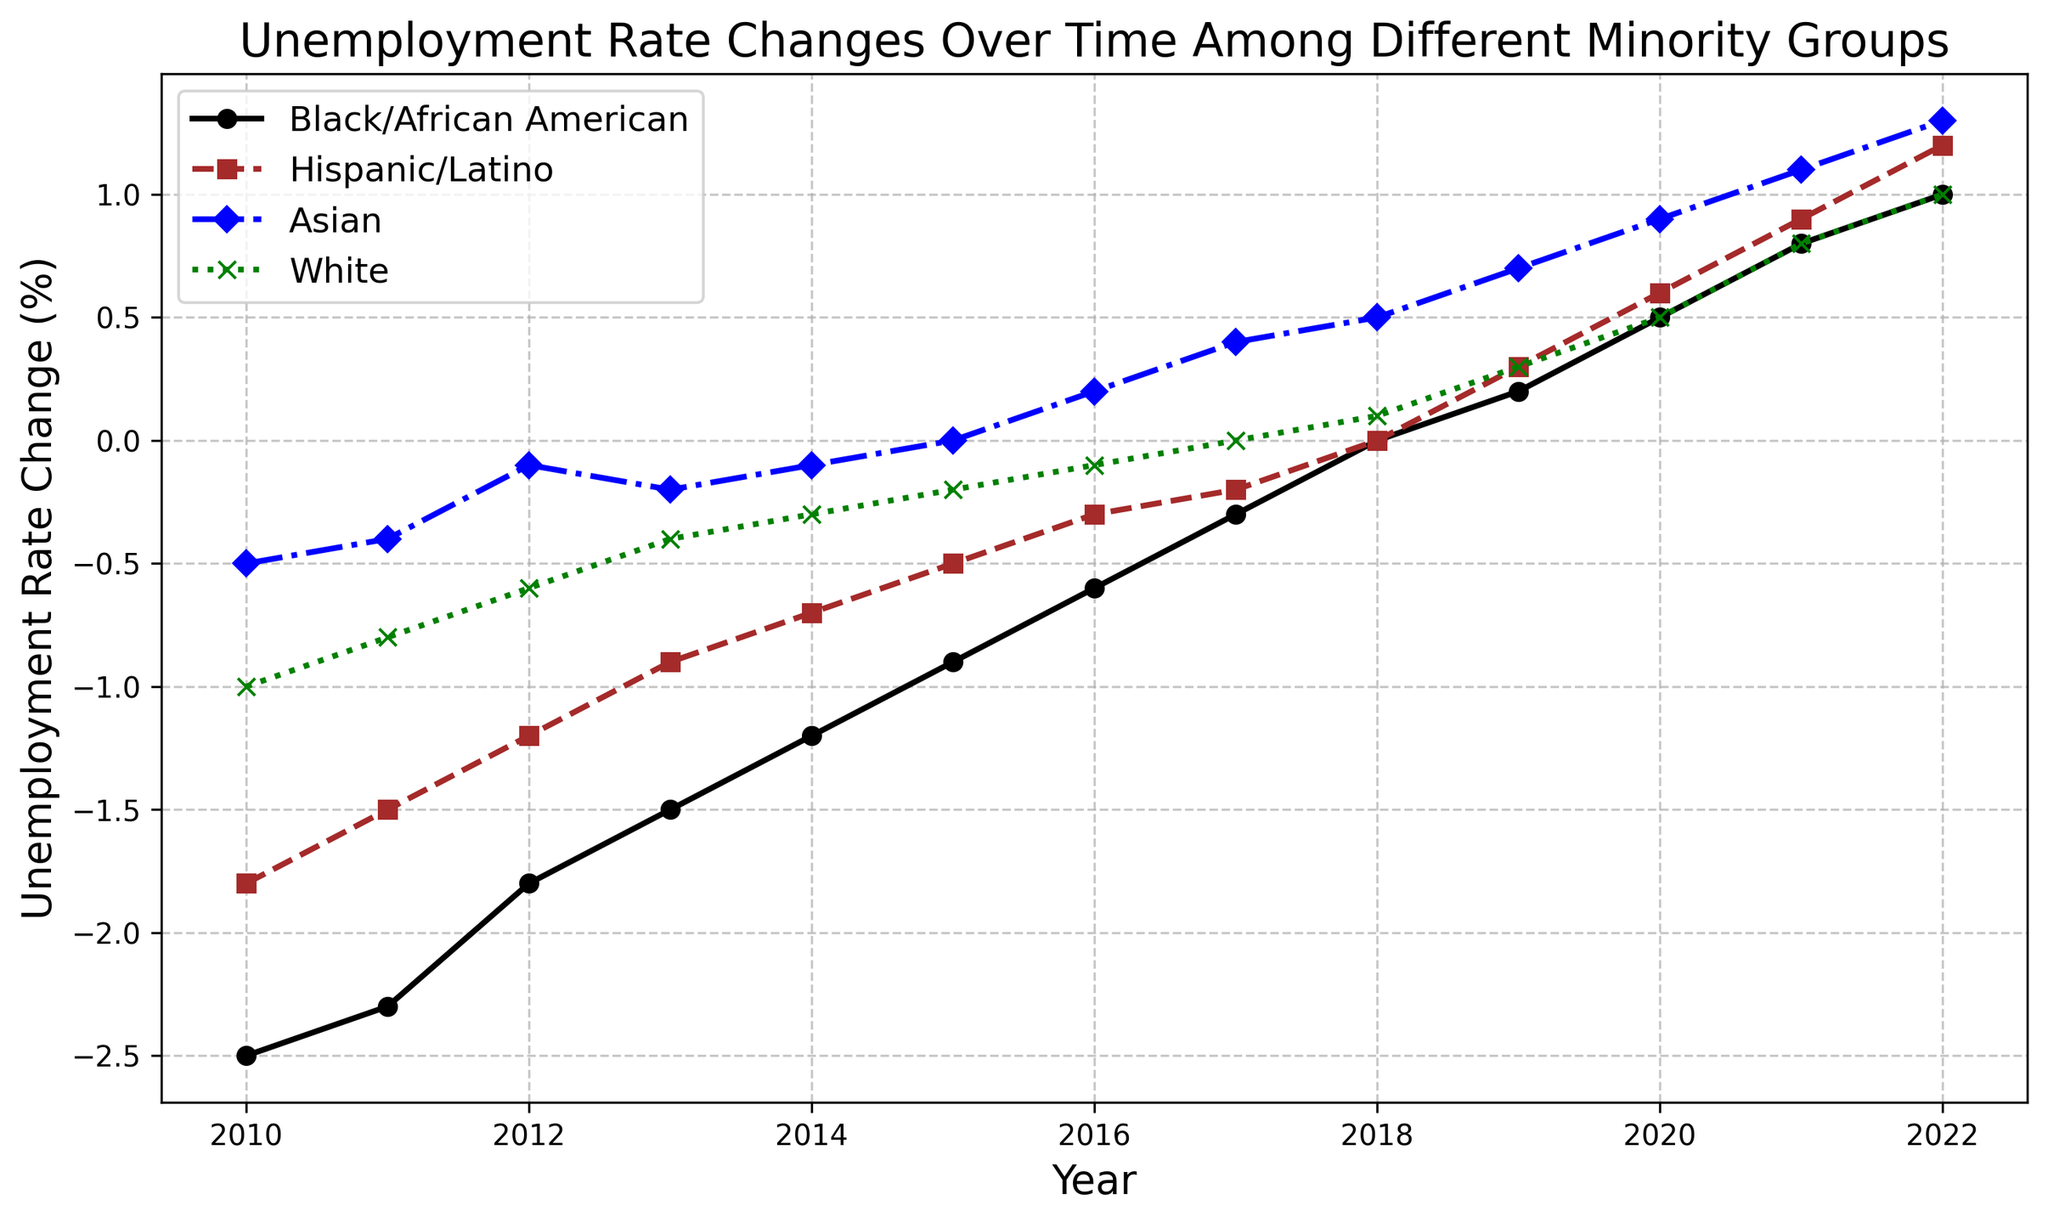What was the unemployment rate change for the Black/African American group in 2018? Locate the line for Black/African American, find the point corresponding to 2018, and read the value. The rate change in 2018 is 0.0.
Answer: 0.0 How did the unemployment rate change for Hispanic/Latino compare to White in 2015? Find the points for both Hispanic/Latino and White in 2015. Hispanic/Latino's change is -0.5, while White's change is -0.2. The Hispanic/Latino group had a larger decrease.
Answer: Hispanic/Latino had a larger decrease Between 2012 and 2018, which group showed the most improvement in unemployment rate? Calculate the difference in unemployment rate change between 2012 and 2018 for each group and compare. Black/African American improved by 1.8 (0.0 - (-1.8)), Hispanic/Latino by 1.2 (0.0 - (-1.2)), Asian by 0.6 (0.5 - (-0.1)), and White by 0.7 (0.1 - (-0.6)).
Answer: Black/African American In what year did the Asian group's unemployment rate change turn positive? Identify the year where the Asian group's value changes from negative to positive. The rate turns positive in 2016 with a value of 0.2.
Answer: 2016 Which group had the highest unemployment rate change in 2022? Look at the values for all groups in 2022. Black/African American, Hispanic/Latino, and Asian are all at 1.3, while White is at 1.0. Thus, Black/African American, Hispanic/Latino, and Asian are tied for the highest.
Answer: Black/African American, Hispanic/Latino, and Asian What is the average unemployment rate change for the White group from 2010 to 2012? Sum the unemployment rate changes for the White group from 2010 to 2012 and divide by the number of years: (-1.0 + (-0.8) + (-0.6))/3 = -2.4/3 = -0.8.
Answer: -0.8 How did the unemployment rate change for the Black/African American group between 2010 and 2022? Subtract the 2010 value from the 2022 value (1.0 - (-2.5)) = 1.0 + 2.5 = 3.5.
Answer: 3.5 During which consecutive three-year period did the Hispanic/Latino group see the greatest improvement in unemployment rate? Calculate the change for each three-year period (e.g., 2010-2013, 2011-2014, etc.). The period 2010-2013 changes from -1.8 to -0.9 (0.9), 2011-2014 changes from -1.5 to -0.7 (0.8), etc. The greatest is 2011-2014 with a 0.8 decrease.
Answer: 2011-2014 